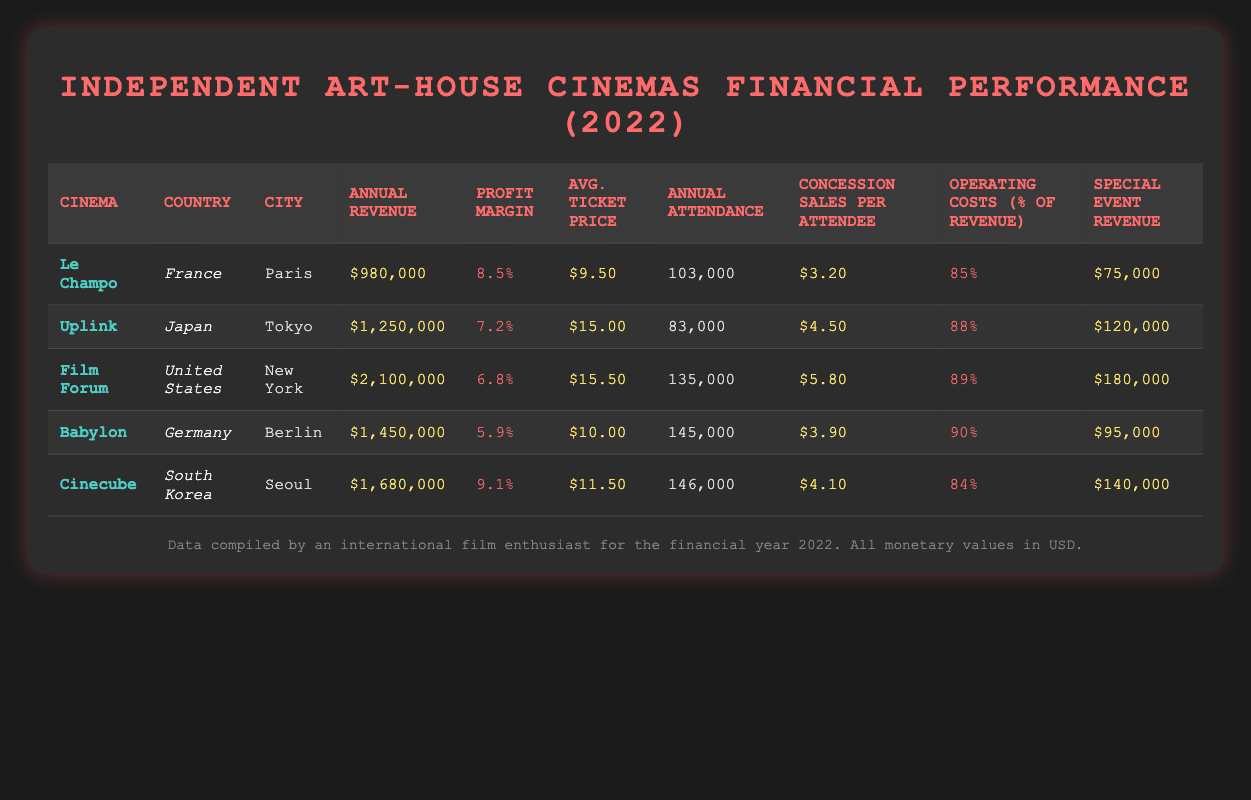What is the highest annual revenue among the cinemas? The annual revenues listed are: $980,000 (Le Champo), $1,250,000 (Uplink), $2,100,000 (Film Forum), $1,450,000 (Babylon), and $1,680,000 (Cinecube). The highest value there is $2,100,000 from Film Forum.
Answer: $2,100,000 Which cinema has the lowest profit margin? The profit margins for the cinemas are: 8.5% (Le Champo), 7.2% (Uplink), 6.8% (Film Forum), 5.9% (Babylon), and 9.1% (Cinecube). The lowest margin is 5.9% from Babylon.
Answer: 5.9% What is the average ticket price across all cinemas? To find the average ticket price, we sum the prices: $9.50 (Le Champo) + $15.00 (Uplink) + $15.50 (Film Forum) + $10.00 (Babylon) + $11.50 (Cinecube) = $61.50. There are 5 cinemas, so the average is $61.50 / 5 = $12.30.
Answer: $12.30 Is Uplink's annual attendance higher than that of Le Champo? The annual attendance for Uplink is 83,000, while for Le Champo it is 103,000. Since 83,000 is less than 103,000, the answer is no.
Answer: No What is the total special event revenue generated by all cinemas? The special event revenues are: $75,000 (Le Champo) + $120,000 (Uplink) + $180,000 (Film Forum) + $95,000 (Babylon) + $140,000 (Cinecube) = $610,000. This is the total special event revenue generated.
Answer: $610,000 Which cinema has the highest concession sales per attendee? The concession sales per attendee are: $3.20 (Le Champo), $4.50 (Uplink), $5.80 (Film Forum), $3.90 (Babylon), and $4.10 (Cinecube). The highest sales per attendee is $5.80 from Film Forum.
Answer: $5.80 What percentage of revenue does Babylon spend in operating costs? The operating costs as a percentage of revenue for Babylon is given as 90%.
Answer: 90% Which country has the cinema with the highest annual attendance? The attendances are: 103,000 (Le Champo), 83,000 (Uplink), 135,000 (Film Forum), 145,000 (Babylon), and 146,000 (Cinecube). The cinema with the highest attendance is Cinecube at 146,000, located in South Korea.
Answer: South Korea Does Film Forum have a higher annual revenue compared to Babylon? Film Forum's annual revenue is $2,100,000, while Babylon's is $1,450,000. Since $2,100,000 is greater than $1,450,000, the answer is yes.
Answer: Yes 